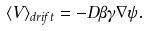Convert formula to latex. <formula><loc_0><loc_0><loc_500><loc_500>\langle { V } \rangle _ { d r i f t } = - D \beta \gamma \nabla \psi .</formula> 